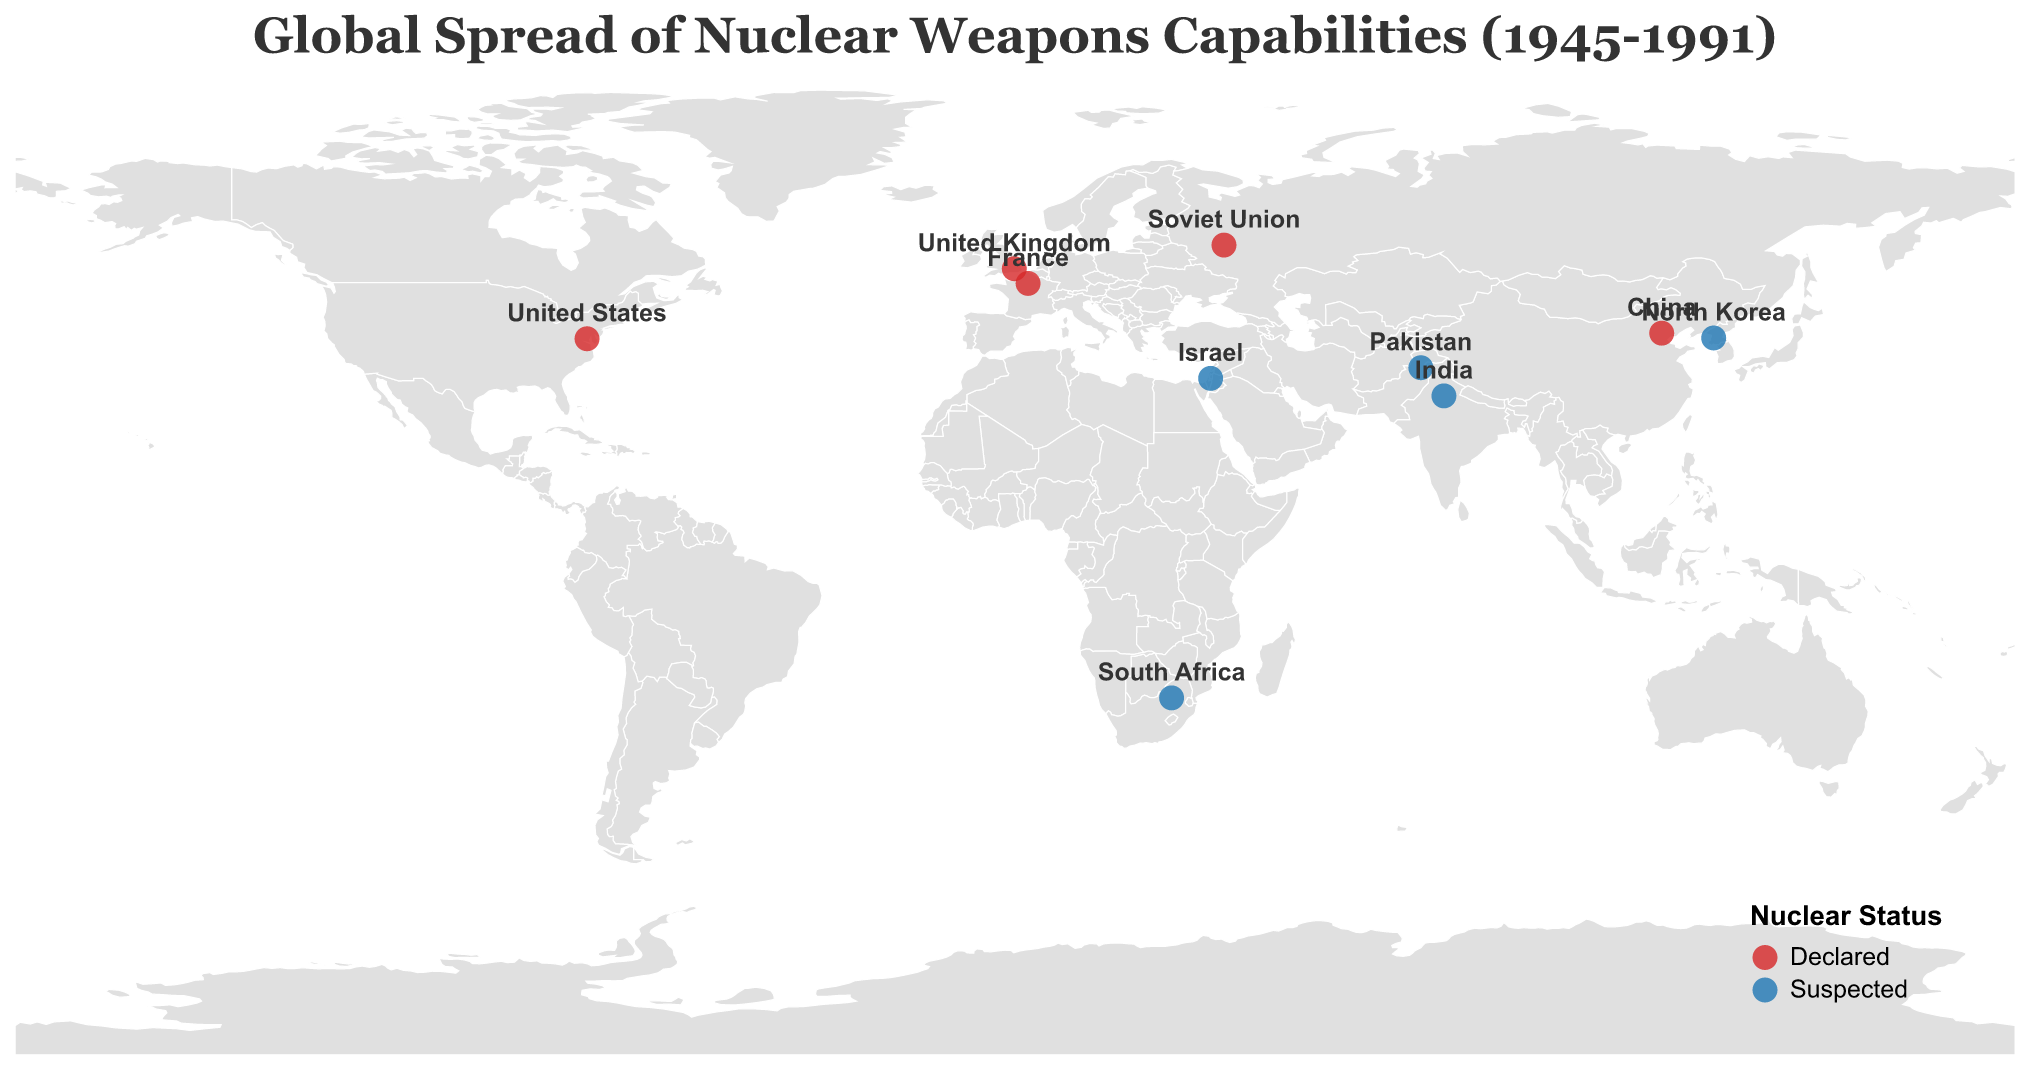What does the map title indicate? The map title "Global Spread of Nuclear Weapons Capabilities (1945-1991)" indicates that the figure displays the spread of nuclear weapons capabilities across the world from 1945 to 1991, involving both declared and suspected nuclear states.
Answer: Global Spread of Nuclear Weapons Capabilities (1945-1991) Which countries are marked as "Declared" nuclear states in the figure? The countries marked as "Declared" nuclear states are represented with a red color. These countries are the United States, Soviet Union, United Kingdom, France, and China.
Answer: United States, Soviet Union, United Kingdom, France, China What is the oldest and newest year shown in the map for the spread of nuclear capabilities? The labels under the 'Year' field in the data reflect the range of years from 1945 to 1989. The earliest year is 1945 (United States) and the latest year is 1989 (North Korea).
Answer: 1945, 1989 How many countries are shown in the figure with "Suspected" nuclear status? The figure displays countries with a blue color to represent those with "Suspected" nuclear status. Counting these countries, we find Israel, India, South Africa, Pakistan, and North Korea. That totals to five countries.
Answer: Five Which country with a "Suspected" nuclear status is located farthest south? By examining the latitude of the countries with a "Suspected" nuclear status, South Africa has the lowest latitude at -25.7461, indicating it is the southernmost.
Answer: South Africa Compare the number of nuclear-capable countries between 1945-1964 to those between 1965-1991. Which period had more countries achieving nuclear capabilities? Identifying the years for each country, we have five countries achieving nuclear capabilities from 1945 to 1964 (United States, Soviet Union, United Kingdom, France, China) and five from 1965 to 1991 (Israel, India, South Africa, Pakistan, North Korea). Both periods had the same number of countries achieving nuclear capabilities.
Answer: They are equal Which continent has the least representation in terms of nuclear capabilities according to the figure? Africa is represented by only one country (South Africa) with suspected nuclear capabilities, making it the least represented continent.
Answer: Africa What trend can you observe about the geographic spread of nuclear capabilities from 1945 to 1991? The geographic spread shows an initial concentration in Europe and North America (e.g., United States, Soviet Union, United Kingdom, France), moving towards Asia and Africa in later years (e.g., China, Israel, India, South Africa, Pakistan, North Korea). This indicates a wider global distribution over time.
Answer: Initial concentration in Europe and North America, then spreading to Asia and Africa 